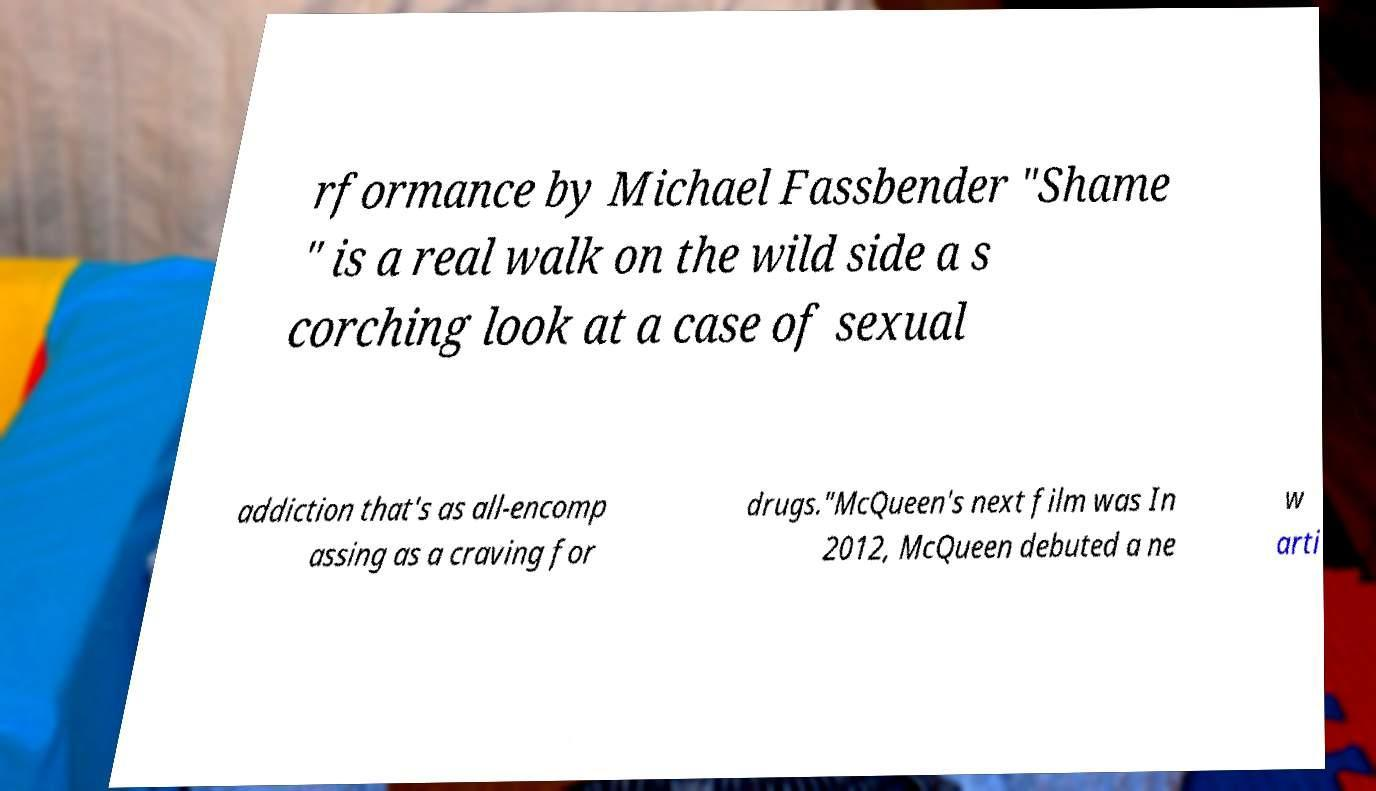Can you read and provide the text displayed in the image?This photo seems to have some interesting text. Can you extract and type it out for me? rformance by Michael Fassbender "Shame " is a real walk on the wild side a s corching look at a case of sexual addiction that's as all-encomp assing as a craving for drugs."McQueen's next film was In 2012, McQueen debuted a ne w arti 